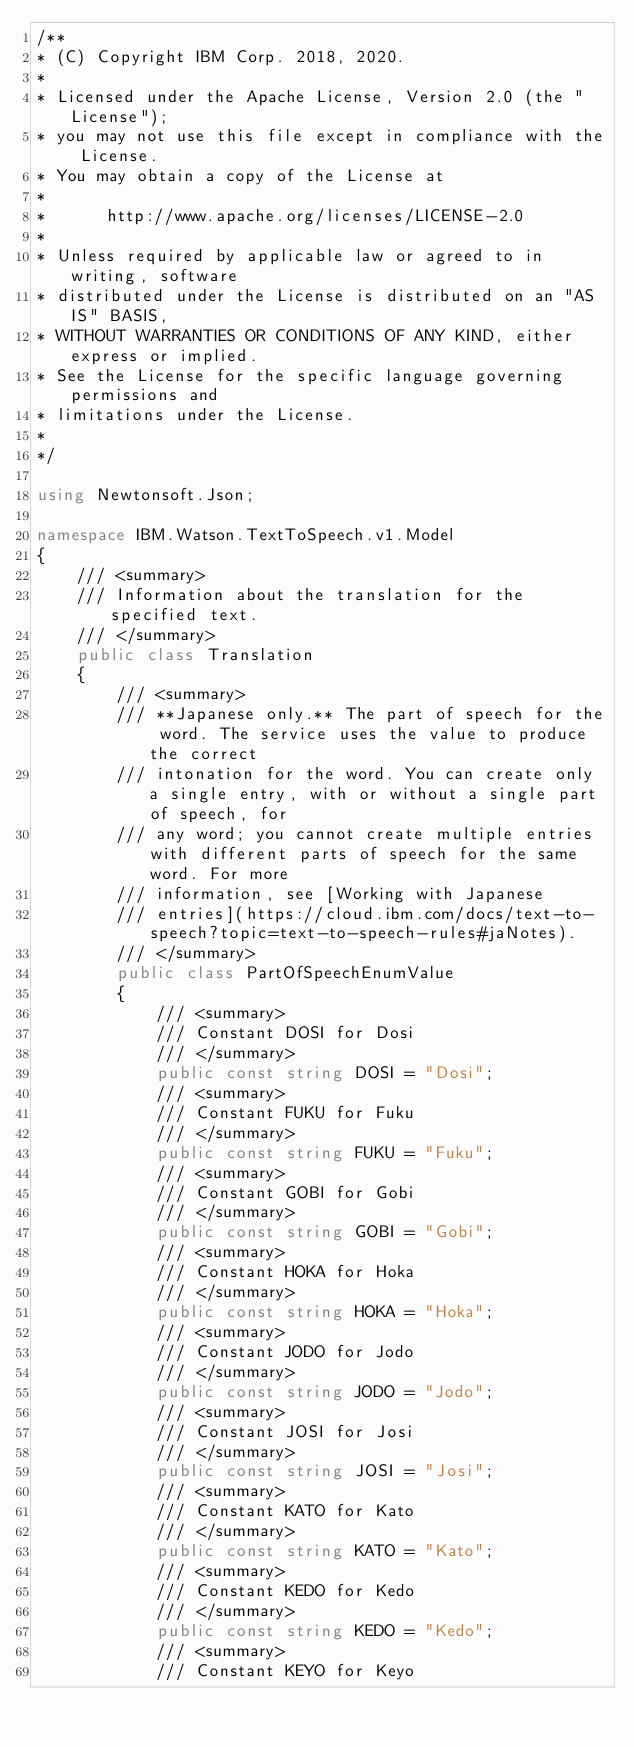<code> <loc_0><loc_0><loc_500><loc_500><_C#_>/**
* (C) Copyright IBM Corp. 2018, 2020.
*
* Licensed under the Apache License, Version 2.0 (the "License");
* you may not use this file except in compliance with the License.
* You may obtain a copy of the License at
*
*      http://www.apache.org/licenses/LICENSE-2.0
*
* Unless required by applicable law or agreed to in writing, software
* distributed under the License is distributed on an "AS IS" BASIS,
* WITHOUT WARRANTIES OR CONDITIONS OF ANY KIND, either express or implied.
* See the License for the specific language governing permissions and
* limitations under the License.
*
*/

using Newtonsoft.Json;

namespace IBM.Watson.TextToSpeech.v1.Model
{
    /// <summary>
    /// Information about the translation for the specified text.
    /// </summary>
    public class Translation
    {
        /// <summary>
        /// **Japanese only.** The part of speech for the word. The service uses the value to produce the correct
        /// intonation for the word. You can create only a single entry, with or without a single part of speech, for
        /// any word; you cannot create multiple entries with different parts of speech for the same word. For more
        /// information, see [Working with Japanese
        /// entries](https://cloud.ibm.com/docs/text-to-speech?topic=text-to-speech-rules#jaNotes).
        /// </summary>
        public class PartOfSpeechEnumValue
        {
            /// <summary>
            /// Constant DOSI for Dosi
            /// </summary>
            public const string DOSI = "Dosi";
            /// <summary>
            /// Constant FUKU for Fuku
            /// </summary>
            public const string FUKU = "Fuku";
            /// <summary>
            /// Constant GOBI for Gobi
            /// </summary>
            public const string GOBI = "Gobi";
            /// <summary>
            /// Constant HOKA for Hoka
            /// </summary>
            public const string HOKA = "Hoka";
            /// <summary>
            /// Constant JODO for Jodo
            /// </summary>
            public const string JODO = "Jodo";
            /// <summary>
            /// Constant JOSI for Josi
            /// </summary>
            public const string JOSI = "Josi";
            /// <summary>
            /// Constant KATO for Kato
            /// </summary>
            public const string KATO = "Kato";
            /// <summary>
            /// Constant KEDO for Kedo
            /// </summary>
            public const string KEDO = "Kedo";
            /// <summary>
            /// Constant KEYO for Keyo</code> 